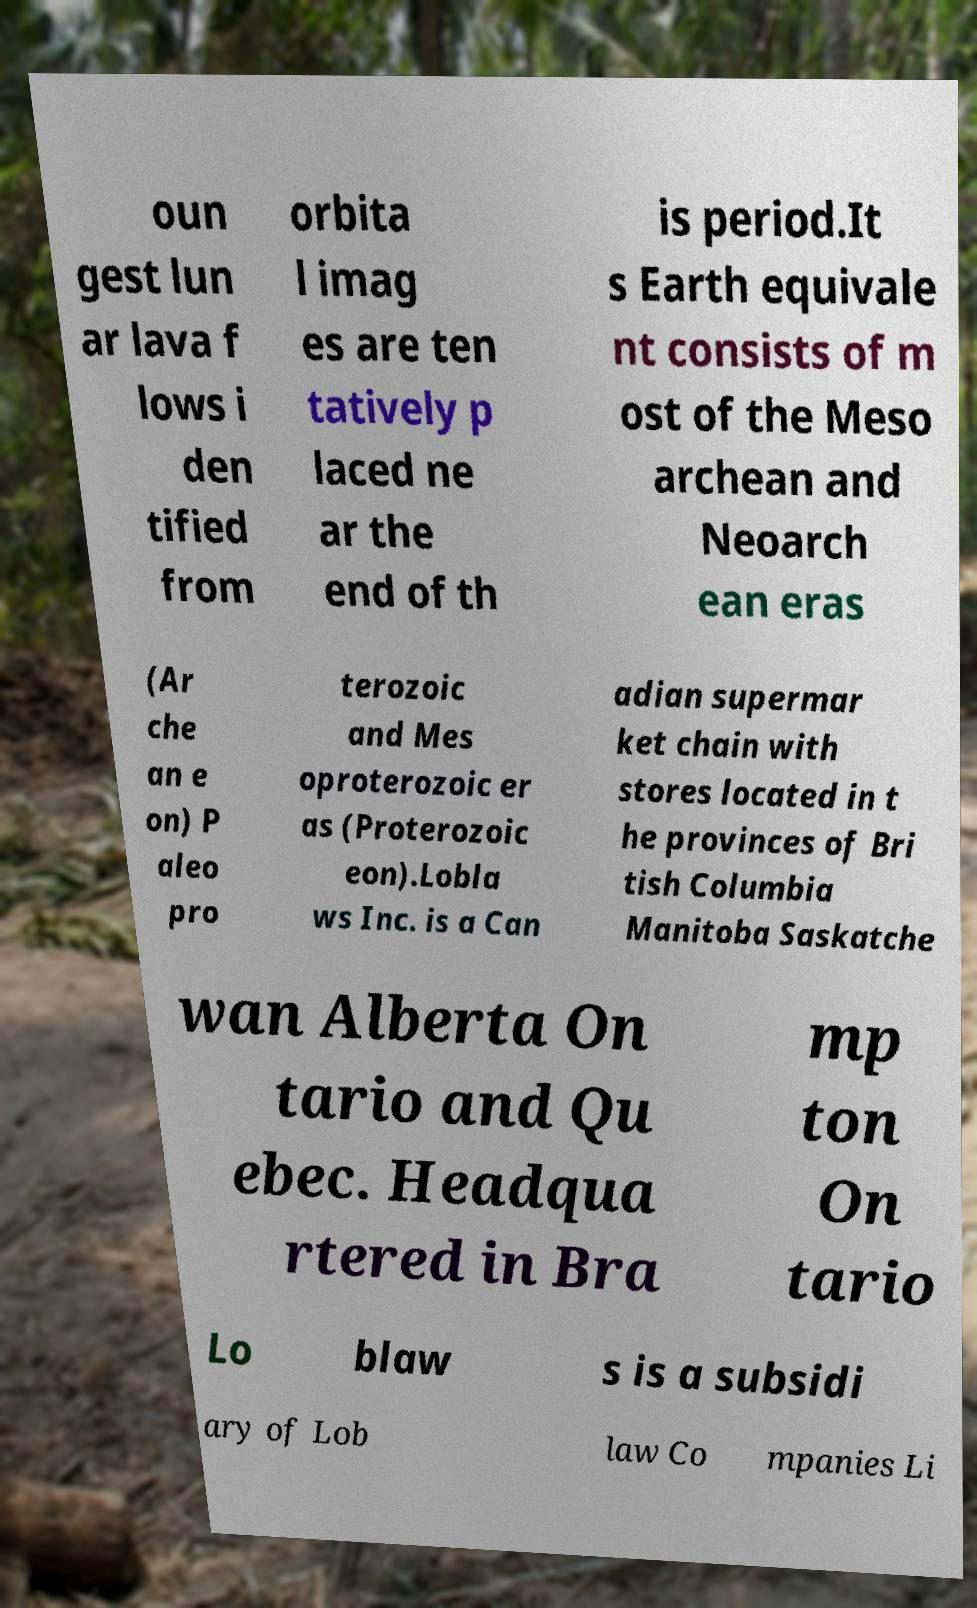For documentation purposes, I need the text within this image transcribed. Could you provide that? oun gest lun ar lava f lows i den tified from orbita l imag es are ten tatively p laced ne ar the end of th is period.It s Earth equivale nt consists of m ost of the Meso archean and Neoarch ean eras (Ar che an e on) P aleo pro terozoic and Mes oproterozoic er as (Proterozoic eon).Lobla ws Inc. is a Can adian supermar ket chain with stores located in t he provinces of Bri tish Columbia Manitoba Saskatche wan Alberta On tario and Qu ebec. Headqua rtered in Bra mp ton On tario Lo blaw s is a subsidi ary of Lob law Co mpanies Li 